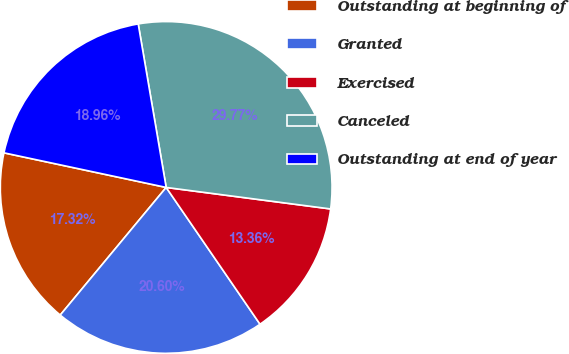<chart> <loc_0><loc_0><loc_500><loc_500><pie_chart><fcel>Outstanding at beginning of<fcel>Granted<fcel>Exercised<fcel>Canceled<fcel>Outstanding at end of year<nl><fcel>17.32%<fcel>20.6%<fcel>13.36%<fcel>29.77%<fcel>18.96%<nl></chart> 